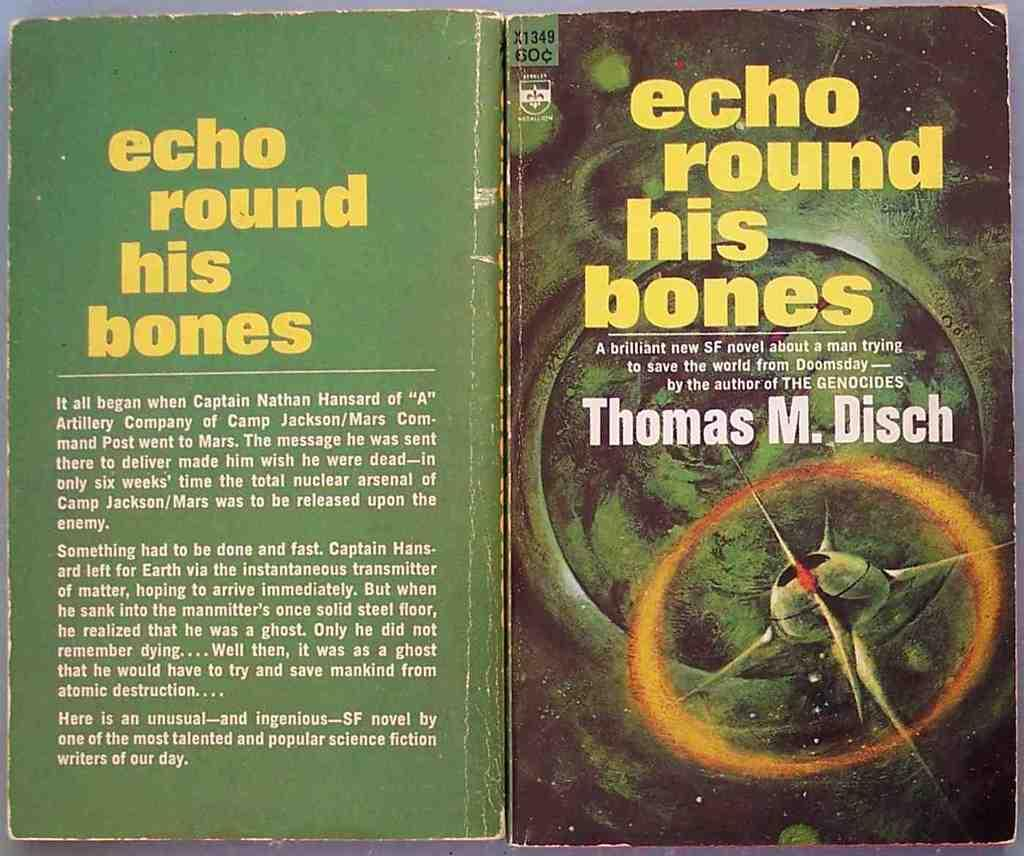<image>
Offer a succinct explanation of the picture presented. old book opened up, echo round his bones by thomas m disch 